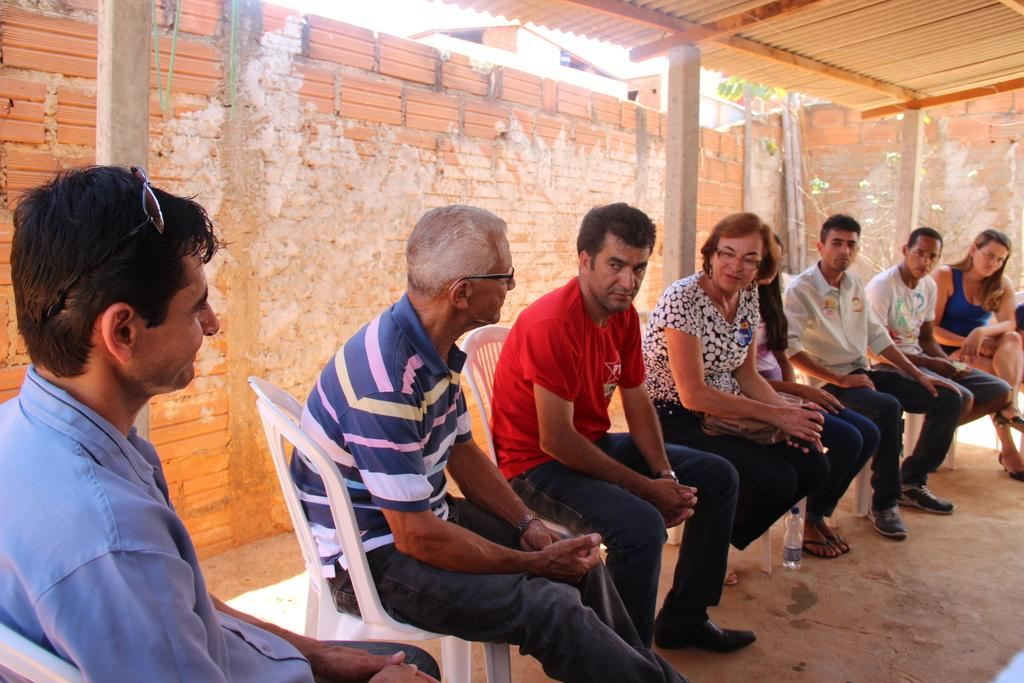How many people are in the image? There are many people in the image. What are the people doing in the image? The people are sitting on chairs. What is visible beneath the people's feet in the image? There is a floor visible in the image. What can be seen behind the people in the image? There is a wall in the background of the image. What structure is located at the top of the image? There is a shed at the top of the image. What type of thread is being used to sew the egg in the image? There is no egg or thread present in the image. How is the bait being used by the people in the image? There is no bait present in the image; the people are sitting on chairs. 